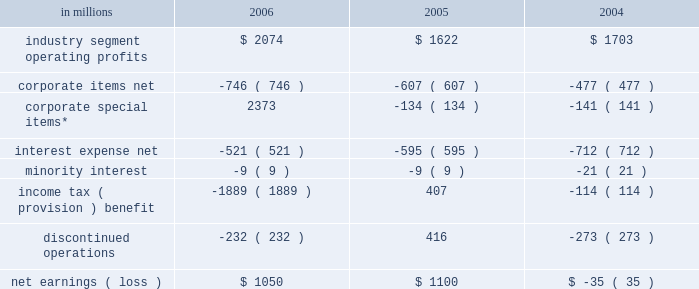Item 7 .
Management 2019s discussion and analysis of financial condition and results of operations executive summary international paper 2019s operating results in 2006 bene- fited from strong gains in pricing and sales volumes and lower operating costs .
Our average paper and packaging prices in 2006 increased faster than our costs for the first time in four years .
The improve- ment in sales volumes reflects increased uncoated papers , corrugated box , coated paperboard and european papers shipments , as well as improved revenues from our xpedx distribution business .
Our manufacturing operations also made solid cost reduction improvements .
Lower interest expense , reflecting debt repayments in 2005 and 2006 , was also a positive factor .
Together , these improvements more than offset the effects of continued high raw material and distribution costs , lower real estate sales , higher net corporate expenses and lower con- tributions from businesses and forestlands divested during 2006 .
Looking forward to 2007 , we expect seasonally higher sales volumes in the first quarter .
Average paper price realizations should continue to improve as we implement previously announced price increases in europe and brazil .
Input costs for energy , fiber and chemicals are expected to be mixed , although slightly higher in the first quarter .
Operating results will benefit from the recently completed international paper/sun paperboard joint ventures in china and the addition of the luiz anto- nio paper mill to our operations in brazil .
However , primarily as a result of lower real estate sales in the first quarter , we anticipate earnings from continuing operations will be somewhat lower than in the 2006 fourth quarter .
Significant steps were also taken in 2006 in the execution of the company 2019s transformation plan .
We completed the sales of our u.s .
And brazilian coated papers businesses and 5.6 million acres of u.s .
Forestlands , and announced definitive sale agreements for our kraft papers , beverage pack- aging and arizona chemical businesses and a majority of our wood products business , all expected to close during 2007 .
Through december 31 , 2006 , we have received approximately $ 9.7 billion of the estimated proceeds from divest- itures announced under this plan of approximately $ 11.3 billion , with the balance to be received as the remaining divestitures are completed in the first half of 2007 .
We have strengthened our balance sheet by reducing debt by $ 6.2 billion , and returned value to our shareholders by repurchasing 39.7 million shares of our common stock for approximately $ 1.4 billion .
We made a $ 1.0 billion voluntary contribution to our u.s .
Qualified pension fund .
We have identified selective reinvestment opportunities totaling approx- imately $ 2.0 billion , including opportunities in china , brazil and russia .
Finally , we remain focused on our three-year $ 1.2 billion target for non-price profit- ability improvements , with $ 330 million realized during 2006 .
While more remains to be done in 2007 , we have made substantial progress toward achiev- ing the objectives announced at the outset of the plan in july 2005 .
Results of operations industry segment operating profits are used by inter- national paper 2019s management to measure the earn- ings performance of its businesses .
Management believes that this measure allows a better under- standing of trends in costs , operating efficiencies , prices and volumes .
Industry segment operating profits are defined as earnings before taxes and minority interest , interest expense , corporate items and corporate special items .
Industry segment oper- ating profits are defined by the securities and exchange commission as a non-gaap financial measure , and are not gaap alternatives to net income or any other operating measure prescribed by accounting principles generally accepted in the united states .
International paper operates in six segments : print- ing papers , industrial packaging , consumer pack- aging , distribution , forest products and specialty businesses and other .
The table shows the components of net earnings ( loss ) for each of the last three years : in millions 2006 2005 2004 .
* corporate special items include gains on transformation plan forestland sales , goodwill impairment charges , restructuring and other charges , net losses on sales and impairments of businesses , insurance recoveries and reversals of reserves no longer required. .
What was the average industry segment operating profits from 2004 to 2006? 
Computations: (1703 + (2074 + 1622))
Answer: 5399.0. 